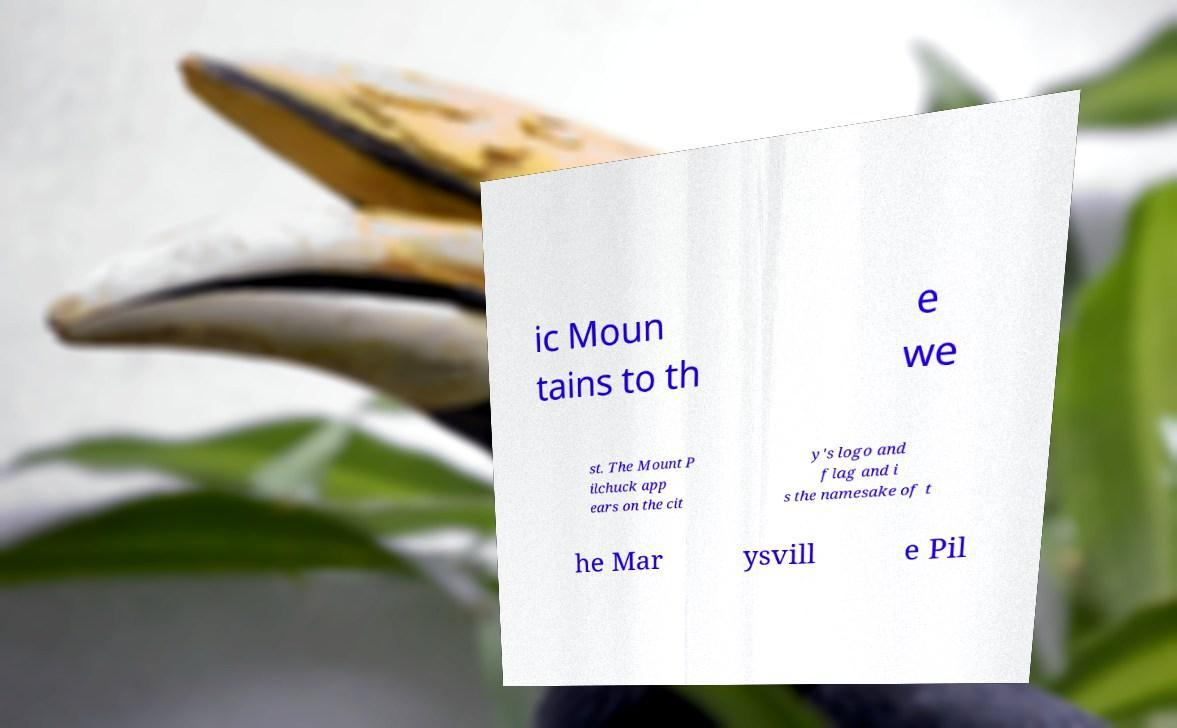What messages or text are displayed in this image? I need them in a readable, typed format. ic Moun tains to th e we st. The Mount P ilchuck app ears on the cit y's logo and flag and i s the namesake of t he Mar ysvill e Pil 